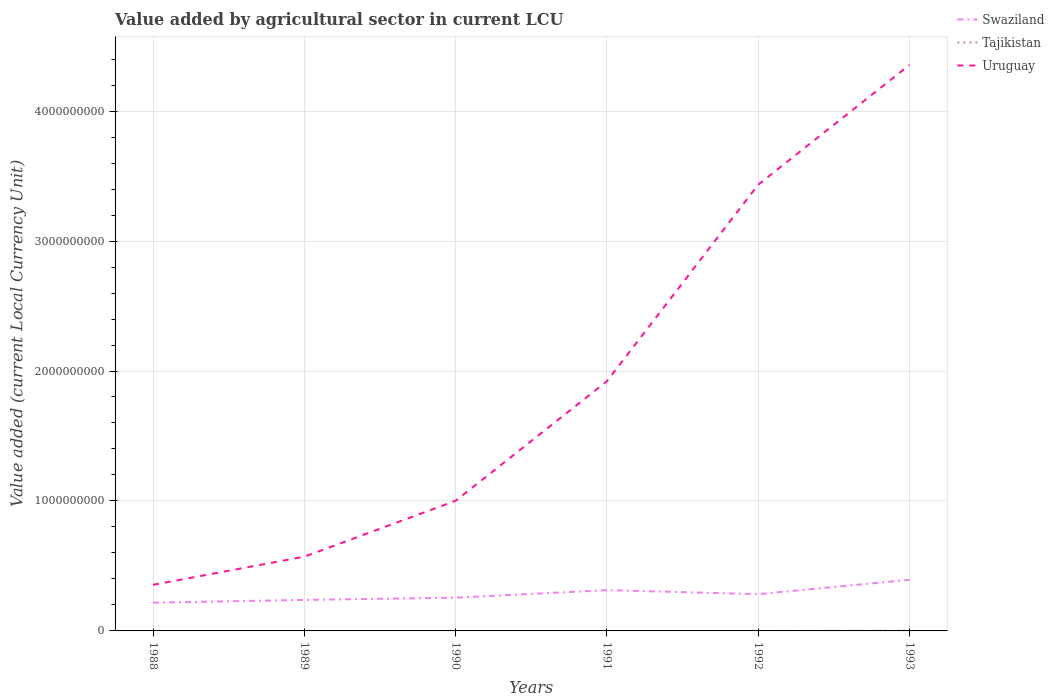How many different coloured lines are there?
Ensure brevity in your answer.  3. Does the line corresponding to Tajikistan intersect with the line corresponding to Swaziland?
Your answer should be very brief. No. Is the number of lines equal to the number of legend labels?
Your answer should be very brief. Yes. Across all years, what is the maximum value added by agricultural sector in Swaziland?
Offer a terse response. 2.17e+08. In which year was the value added by agricultural sector in Uruguay maximum?
Give a very brief answer. 1988. What is the total value added by agricultural sector in Tajikistan in the graph?
Your answer should be compact. -1.43e+06. What is the difference between the highest and the second highest value added by agricultural sector in Swaziland?
Give a very brief answer. 1.76e+08. How many lines are there?
Keep it short and to the point. 3. How many years are there in the graph?
Offer a terse response. 6. What is the difference between two consecutive major ticks on the Y-axis?
Ensure brevity in your answer.  1.00e+09. Where does the legend appear in the graph?
Ensure brevity in your answer.  Top right. How many legend labels are there?
Your answer should be compact. 3. How are the legend labels stacked?
Your response must be concise. Vertical. What is the title of the graph?
Keep it short and to the point. Value added by agricultural sector in current LCU. What is the label or title of the X-axis?
Offer a terse response. Years. What is the label or title of the Y-axis?
Ensure brevity in your answer.  Value added (current Local Currency Unit). What is the Value added (current Local Currency Unit) in Swaziland in 1988?
Offer a terse response. 2.17e+08. What is the Value added (current Local Currency Unit) of Tajikistan in 1988?
Ensure brevity in your answer.  2.18e+04. What is the Value added (current Local Currency Unit) of Uruguay in 1988?
Your answer should be compact. 3.55e+08. What is the Value added (current Local Currency Unit) in Swaziland in 1989?
Make the answer very short. 2.38e+08. What is the Value added (current Local Currency Unit) in Tajikistan in 1989?
Your answer should be very brief. 2.21e+04. What is the Value added (current Local Currency Unit) in Uruguay in 1989?
Ensure brevity in your answer.  5.71e+08. What is the Value added (current Local Currency Unit) in Swaziland in 1990?
Your response must be concise. 2.56e+08. What is the Value added (current Local Currency Unit) of Tajikistan in 1990?
Ensure brevity in your answer.  2.43e+04. What is the Value added (current Local Currency Unit) in Uruguay in 1990?
Give a very brief answer. 1.00e+09. What is the Value added (current Local Currency Unit) in Swaziland in 1991?
Keep it short and to the point. 3.14e+08. What is the Value added (current Local Currency Unit) in Tajikistan in 1991?
Provide a short and direct response. 4.88e+04. What is the Value added (current Local Currency Unit) of Uruguay in 1991?
Offer a very short reply. 1.92e+09. What is the Value added (current Local Currency Unit) of Swaziland in 1992?
Offer a terse response. 2.83e+08. What is the Value added (current Local Currency Unit) in Tajikistan in 1992?
Ensure brevity in your answer.  1.91e+05. What is the Value added (current Local Currency Unit) in Uruguay in 1992?
Offer a terse response. 3.43e+09. What is the Value added (current Local Currency Unit) of Swaziland in 1993?
Your answer should be very brief. 3.93e+08. What is the Value added (current Local Currency Unit) of Tajikistan in 1993?
Your answer should be very brief. 1.48e+06. What is the Value added (current Local Currency Unit) in Uruguay in 1993?
Your answer should be very brief. 4.36e+09. Across all years, what is the maximum Value added (current Local Currency Unit) in Swaziland?
Keep it short and to the point. 3.93e+08. Across all years, what is the maximum Value added (current Local Currency Unit) of Tajikistan?
Keep it short and to the point. 1.48e+06. Across all years, what is the maximum Value added (current Local Currency Unit) in Uruguay?
Your answer should be compact. 4.36e+09. Across all years, what is the minimum Value added (current Local Currency Unit) in Swaziland?
Provide a short and direct response. 2.17e+08. Across all years, what is the minimum Value added (current Local Currency Unit) of Tajikistan?
Offer a very short reply. 2.18e+04. Across all years, what is the minimum Value added (current Local Currency Unit) of Uruguay?
Your answer should be compact. 3.55e+08. What is the total Value added (current Local Currency Unit) in Swaziland in the graph?
Give a very brief answer. 1.70e+09. What is the total Value added (current Local Currency Unit) in Tajikistan in the graph?
Ensure brevity in your answer.  1.79e+06. What is the total Value added (current Local Currency Unit) in Uruguay in the graph?
Your answer should be compact. 1.16e+1. What is the difference between the Value added (current Local Currency Unit) in Swaziland in 1988 and that in 1989?
Offer a very short reply. -2.12e+07. What is the difference between the Value added (current Local Currency Unit) in Tajikistan in 1988 and that in 1989?
Ensure brevity in your answer.  -336.47. What is the difference between the Value added (current Local Currency Unit) in Uruguay in 1988 and that in 1989?
Offer a terse response. -2.17e+08. What is the difference between the Value added (current Local Currency Unit) in Swaziland in 1988 and that in 1990?
Keep it short and to the point. -3.86e+07. What is the difference between the Value added (current Local Currency Unit) of Tajikistan in 1988 and that in 1990?
Offer a terse response. -2468.71. What is the difference between the Value added (current Local Currency Unit) in Uruguay in 1988 and that in 1990?
Offer a terse response. -6.47e+08. What is the difference between the Value added (current Local Currency Unit) in Swaziland in 1988 and that in 1991?
Offer a very short reply. -9.66e+07. What is the difference between the Value added (current Local Currency Unit) in Tajikistan in 1988 and that in 1991?
Keep it short and to the point. -2.70e+04. What is the difference between the Value added (current Local Currency Unit) in Uruguay in 1988 and that in 1991?
Offer a very short reply. -1.57e+09. What is the difference between the Value added (current Local Currency Unit) of Swaziland in 1988 and that in 1992?
Your answer should be very brief. -6.56e+07. What is the difference between the Value added (current Local Currency Unit) of Tajikistan in 1988 and that in 1992?
Offer a terse response. -1.69e+05. What is the difference between the Value added (current Local Currency Unit) in Uruguay in 1988 and that in 1992?
Provide a short and direct response. -3.08e+09. What is the difference between the Value added (current Local Currency Unit) in Swaziland in 1988 and that in 1993?
Your answer should be very brief. -1.76e+08. What is the difference between the Value added (current Local Currency Unit) in Tajikistan in 1988 and that in 1993?
Make the answer very short. -1.46e+06. What is the difference between the Value added (current Local Currency Unit) of Uruguay in 1988 and that in 1993?
Provide a short and direct response. -4.00e+09. What is the difference between the Value added (current Local Currency Unit) of Swaziland in 1989 and that in 1990?
Provide a succinct answer. -1.74e+07. What is the difference between the Value added (current Local Currency Unit) in Tajikistan in 1989 and that in 1990?
Offer a very short reply. -2132.24. What is the difference between the Value added (current Local Currency Unit) in Uruguay in 1989 and that in 1990?
Your response must be concise. -4.30e+08. What is the difference between the Value added (current Local Currency Unit) of Swaziland in 1989 and that in 1991?
Keep it short and to the point. -7.54e+07. What is the difference between the Value added (current Local Currency Unit) of Tajikistan in 1989 and that in 1991?
Offer a terse response. -2.66e+04. What is the difference between the Value added (current Local Currency Unit) of Uruguay in 1989 and that in 1991?
Provide a short and direct response. -1.35e+09. What is the difference between the Value added (current Local Currency Unit) in Swaziland in 1989 and that in 1992?
Make the answer very short. -4.44e+07. What is the difference between the Value added (current Local Currency Unit) in Tajikistan in 1989 and that in 1992?
Offer a very short reply. -1.69e+05. What is the difference between the Value added (current Local Currency Unit) of Uruguay in 1989 and that in 1992?
Your answer should be very brief. -2.86e+09. What is the difference between the Value added (current Local Currency Unit) in Swaziland in 1989 and that in 1993?
Offer a terse response. -1.55e+08. What is the difference between the Value added (current Local Currency Unit) of Tajikistan in 1989 and that in 1993?
Provide a short and direct response. -1.46e+06. What is the difference between the Value added (current Local Currency Unit) of Uruguay in 1989 and that in 1993?
Keep it short and to the point. -3.78e+09. What is the difference between the Value added (current Local Currency Unit) of Swaziland in 1990 and that in 1991?
Offer a very short reply. -5.80e+07. What is the difference between the Value added (current Local Currency Unit) in Tajikistan in 1990 and that in 1991?
Your response must be concise. -2.45e+04. What is the difference between the Value added (current Local Currency Unit) in Uruguay in 1990 and that in 1991?
Make the answer very short. -9.20e+08. What is the difference between the Value added (current Local Currency Unit) in Swaziland in 1990 and that in 1992?
Your response must be concise. -2.70e+07. What is the difference between the Value added (current Local Currency Unit) of Tajikistan in 1990 and that in 1992?
Provide a succinct answer. -1.67e+05. What is the difference between the Value added (current Local Currency Unit) in Uruguay in 1990 and that in 1992?
Make the answer very short. -2.43e+09. What is the difference between the Value added (current Local Currency Unit) in Swaziland in 1990 and that in 1993?
Provide a short and direct response. -1.38e+08. What is the difference between the Value added (current Local Currency Unit) of Tajikistan in 1990 and that in 1993?
Offer a terse response. -1.46e+06. What is the difference between the Value added (current Local Currency Unit) of Uruguay in 1990 and that in 1993?
Keep it short and to the point. -3.35e+09. What is the difference between the Value added (current Local Currency Unit) in Swaziland in 1991 and that in 1992?
Provide a succinct answer. 3.10e+07. What is the difference between the Value added (current Local Currency Unit) of Tajikistan in 1991 and that in 1992?
Make the answer very short. -1.42e+05. What is the difference between the Value added (current Local Currency Unit) of Uruguay in 1991 and that in 1992?
Provide a short and direct response. -1.51e+09. What is the difference between the Value added (current Local Currency Unit) of Swaziland in 1991 and that in 1993?
Offer a terse response. -7.95e+07. What is the difference between the Value added (current Local Currency Unit) in Tajikistan in 1991 and that in 1993?
Give a very brief answer. -1.43e+06. What is the difference between the Value added (current Local Currency Unit) in Uruguay in 1991 and that in 1993?
Provide a succinct answer. -2.43e+09. What is the difference between the Value added (current Local Currency Unit) of Swaziland in 1992 and that in 1993?
Offer a terse response. -1.11e+08. What is the difference between the Value added (current Local Currency Unit) of Tajikistan in 1992 and that in 1993?
Offer a very short reply. -1.29e+06. What is the difference between the Value added (current Local Currency Unit) in Uruguay in 1992 and that in 1993?
Offer a very short reply. -9.22e+08. What is the difference between the Value added (current Local Currency Unit) of Swaziland in 1988 and the Value added (current Local Currency Unit) of Tajikistan in 1989?
Offer a very short reply. 2.17e+08. What is the difference between the Value added (current Local Currency Unit) in Swaziland in 1988 and the Value added (current Local Currency Unit) in Uruguay in 1989?
Offer a very short reply. -3.54e+08. What is the difference between the Value added (current Local Currency Unit) in Tajikistan in 1988 and the Value added (current Local Currency Unit) in Uruguay in 1989?
Give a very brief answer. -5.71e+08. What is the difference between the Value added (current Local Currency Unit) of Swaziland in 1988 and the Value added (current Local Currency Unit) of Tajikistan in 1990?
Offer a very short reply. 2.17e+08. What is the difference between the Value added (current Local Currency Unit) of Swaziland in 1988 and the Value added (current Local Currency Unit) of Uruguay in 1990?
Give a very brief answer. -7.84e+08. What is the difference between the Value added (current Local Currency Unit) in Tajikistan in 1988 and the Value added (current Local Currency Unit) in Uruguay in 1990?
Keep it short and to the point. -1.00e+09. What is the difference between the Value added (current Local Currency Unit) of Swaziland in 1988 and the Value added (current Local Currency Unit) of Tajikistan in 1991?
Make the answer very short. 2.17e+08. What is the difference between the Value added (current Local Currency Unit) in Swaziland in 1988 and the Value added (current Local Currency Unit) in Uruguay in 1991?
Provide a short and direct response. -1.70e+09. What is the difference between the Value added (current Local Currency Unit) of Tajikistan in 1988 and the Value added (current Local Currency Unit) of Uruguay in 1991?
Your response must be concise. -1.92e+09. What is the difference between the Value added (current Local Currency Unit) of Swaziland in 1988 and the Value added (current Local Currency Unit) of Tajikistan in 1992?
Offer a terse response. 2.17e+08. What is the difference between the Value added (current Local Currency Unit) in Swaziland in 1988 and the Value added (current Local Currency Unit) in Uruguay in 1992?
Your response must be concise. -3.22e+09. What is the difference between the Value added (current Local Currency Unit) in Tajikistan in 1988 and the Value added (current Local Currency Unit) in Uruguay in 1992?
Make the answer very short. -3.43e+09. What is the difference between the Value added (current Local Currency Unit) in Swaziland in 1988 and the Value added (current Local Currency Unit) in Tajikistan in 1993?
Provide a short and direct response. 2.16e+08. What is the difference between the Value added (current Local Currency Unit) in Swaziland in 1988 and the Value added (current Local Currency Unit) in Uruguay in 1993?
Your answer should be very brief. -4.14e+09. What is the difference between the Value added (current Local Currency Unit) of Tajikistan in 1988 and the Value added (current Local Currency Unit) of Uruguay in 1993?
Give a very brief answer. -4.36e+09. What is the difference between the Value added (current Local Currency Unit) of Swaziland in 1989 and the Value added (current Local Currency Unit) of Tajikistan in 1990?
Make the answer very short. 2.38e+08. What is the difference between the Value added (current Local Currency Unit) in Swaziland in 1989 and the Value added (current Local Currency Unit) in Uruguay in 1990?
Make the answer very short. -7.63e+08. What is the difference between the Value added (current Local Currency Unit) in Tajikistan in 1989 and the Value added (current Local Currency Unit) in Uruguay in 1990?
Provide a short and direct response. -1.00e+09. What is the difference between the Value added (current Local Currency Unit) in Swaziland in 1989 and the Value added (current Local Currency Unit) in Tajikistan in 1991?
Provide a short and direct response. 2.38e+08. What is the difference between the Value added (current Local Currency Unit) of Swaziland in 1989 and the Value added (current Local Currency Unit) of Uruguay in 1991?
Your response must be concise. -1.68e+09. What is the difference between the Value added (current Local Currency Unit) in Tajikistan in 1989 and the Value added (current Local Currency Unit) in Uruguay in 1991?
Your answer should be compact. -1.92e+09. What is the difference between the Value added (current Local Currency Unit) of Swaziland in 1989 and the Value added (current Local Currency Unit) of Tajikistan in 1992?
Offer a very short reply. 2.38e+08. What is the difference between the Value added (current Local Currency Unit) of Swaziland in 1989 and the Value added (current Local Currency Unit) of Uruguay in 1992?
Your answer should be very brief. -3.20e+09. What is the difference between the Value added (current Local Currency Unit) of Tajikistan in 1989 and the Value added (current Local Currency Unit) of Uruguay in 1992?
Your answer should be compact. -3.43e+09. What is the difference between the Value added (current Local Currency Unit) of Swaziland in 1989 and the Value added (current Local Currency Unit) of Tajikistan in 1993?
Offer a terse response. 2.37e+08. What is the difference between the Value added (current Local Currency Unit) in Swaziland in 1989 and the Value added (current Local Currency Unit) in Uruguay in 1993?
Offer a terse response. -4.12e+09. What is the difference between the Value added (current Local Currency Unit) in Tajikistan in 1989 and the Value added (current Local Currency Unit) in Uruguay in 1993?
Make the answer very short. -4.36e+09. What is the difference between the Value added (current Local Currency Unit) of Swaziland in 1990 and the Value added (current Local Currency Unit) of Tajikistan in 1991?
Your response must be concise. 2.56e+08. What is the difference between the Value added (current Local Currency Unit) in Swaziland in 1990 and the Value added (current Local Currency Unit) in Uruguay in 1991?
Provide a short and direct response. -1.67e+09. What is the difference between the Value added (current Local Currency Unit) of Tajikistan in 1990 and the Value added (current Local Currency Unit) of Uruguay in 1991?
Give a very brief answer. -1.92e+09. What is the difference between the Value added (current Local Currency Unit) of Swaziland in 1990 and the Value added (current Local Currency Unit) of Tajikistan in 1992?
Provide a succinct answer. 2.56e+08. What is the difference between the Value added (current Local Currency Unit) of Swaziland in 1990 and the Value added (current Local Currency Unit) of Uruguay in 1992?
Ensure brevity in your answer.  -3.18e+09. What is the difference between the Value added (current Local Currency Unit) of Tajikistan in 1990 and the Value added (current Local Currency Unit) of Uruguay in 1992?
Give a very brief answer. -3.43e+09. What is the difference between the Value added (current Local Currency Unit) of Swaziland in 1990 and the Value added (current Local Currency Unit) of Tajikistan in 1993?
Offer a very short reply. 2.54e+08. What is the difference between the Value added (current Local Currency Unit) of Swaziland in 1990 and the Value added (current Local Currency Unit) of Uruguay in 1993?
Give a very brief answer. -4.10e+09. What is the difference between the Value added (current Local Currency Unit) of Tajikistan in 1990 and the Value added (current Local Currency Unit) of Uruguay in 1993?
Offer a very short reply. -4.36e+09. What is the difference between the Value added (current Local Currency Unit) of Swaziland in 1991 and the Value added (current Local Currency Unit) of Tajikistan in 1992?
Your answer should be very brief. 3.14e+08. What is the difference between the Value added (current Local Currency Unit) in Swaziland in 1991 and the Value added (current Local Currency Unit) in Uruguay in 1992?
Keep it short and to the point. -3.12e+09. What is the difference between the Value added (current Local Currency Unit) of Tajikistan in 1991 and the Value added (current Local Currency Unit) of Uruguay in 1992?
Your answer should be very brief. -3.43e+09. What is the difference between the Value added (current Local Currency Unit) of Swaziland in 1991 and the Value added (current Local Currency Unit) of Tajikistan in 1993?
Provide a succinct answer. 3.12e+08. What is the difference between the Value added (current Local Currency Unit) in Swaziland in 1991 and the Value added (current Local Currency Unit) in Uruguay in 1993?
Offer a very short reply. -4.04e+09. What is the difference between the Value added (current Local Currency Unit) of Tajikistan in 1991 and the Value added (current Local Currency Unit) of Uruguay in 1993?
Provide a succinct answer. -4.36e+09. What is the difference between the Value added (current Local Currency Unit) in Swaziland in 1992 and the Value added (current Local Currency Unit) in Tajikistan in 1993?
Keep it short and to the point. 2.81e+08. What is the difference between the Value added (current Local Currency Unit) of Swaziland in 1992 and the Value added (current Local Currency Unit) of Uruguay in 1993?
Your answer should be very brief. -4.07e+09. What is the difference between the Value added (current Local Currency Unit) in Tajikistan in 1992 and the Value added (current Local Currency Unit) in Uruguay in 1993?
Offer a terse response. -4.36e+09. What is the average Value added (current Local Currency Unit) of Swaziland per year?
Your answer should be very brief. 2.84e+08. What is the average Value added (current Local Currency Unit) of Tajikistan per year?
Make the answer very short. 2.99e+05. What is the average Value added (current Local Currency Unit) in Uruguay per year?
Provide a short and direct response. 1.94e+09. In the year 1988, what is the difference between the Value added (current Local Currency Unit) of Swaziland and Value added (current Local Currency Unit) of Tajikistan?
Your response must be concise. 2.17e+08. In the year 1988, what is the difference between the Value added (current Local Currency Unit) in Swaziland and Value added (current Local Currency Unit) in Uruguay?
Your response must be concise. -1.37e+08. In the year 1988, what is the difference between the Value added (current Local Currency Unit) of Tajikistan and Value added (current Local Currency Unit) of Uruguay?
Give a very brief answer. -3.55e+08. In the year 1989, what is the difference between the Value added (current Local Currency Unit) of Swaziland and Value added (current Local Currency Unit) of Tajikistan?
Offer a very short reply. 2.38e+08. In the year 1989, what is the difference between the Value added (current Local Currency Unit) of Swaziland and Value added (current Local Currency Unit) of Uruguay?
Your answer should be very brief. -3.33e+08. In the year 1989, what is the difference between the Value added (current Local Currency Unit) in Tajikistan and Value added (current Local Currency Unit) in Uruguay?
Offer a very short reply. -5.71e+08. In the year 1990, what is the difference between the Value added (current Local Currency Unit) of Swaziland and Value added (current Local Currency Unit) of Tajikistan?
Provide a succinct answer. 2.56e+08. In the year 1990, what is the difference between the Value added (current Local Currency Unit) of Swaziland and Value added (current Local Currency Unit) of Uruguay?
Make the answer very short. -7.46e+08. In the year 1990, what is the difference between the Value added (current Local Currency Unit) of Tajikistan and Value added (current Local Currency Unit) of Uruguay?
Offer a terse response. -1.00e+09. In the year 1991, what is the difference between the Value added (current Local Currency Unit) of Swaziland and Value added (current Local Currency Unit) of Tajikistan?
Your answer should be very brief. 3.14e+08. In the year 1991, what is the difference between the Value added (current Local Currency Unit) in Swaziland and Value added (current Local Currency Unit) in Uruguay?
Your answer should be compact. -1.61e+09. In the year 1991, what is the difference between the Value added (current Local Currency Unit) in Tajikistan and Value added (current Local Currency Unit) in Uruguay?
Offer a very short reply. -1.92e+09. In the year 1992, what is the difference between the Value added (current Local Currency Unit) of Swaziland and Value added (current Local Currency Unit) of Tajikistan?
Keep it short and to the point. 2.83e+08. In the year 1992, what is the difference between the Value added (current Local Currency Unit) of Swaziland and Value added (current Local Currency Unit) of Uruguay?
Your answer should be compact. -3.15e+09. In the year 1992, what is the difference between the Value added (current Local Currency Unit) of Tajikistan and Value added (current Local Currency Unit) of Uruguay?
Your response must be concise. -3.43e+09. In the year 1993, what is the difference between the Value added (current Local Currency Unit) in Swaziland and Value added (current Local Currency Unit) in Tajikistan?
Your answer should be compact. 3.92e+08. In the year 1993, what is the difference between the Value added (current Local Currency Unit) of Swaziland and Value added (current Local Currency Unit) of Uruguay?
Offer a terse response. -3.96e+09. In the year 1993, what is the difference between the Value added (current Local Currency Unit) of Tajikistan and Value added (current Local Currency Unit) of Uruguay?
Give a very brief answer. -4.35e+09. What is the ratio of the Value added (current Local Currency Unit) of Swaziland in 1988 to that in 1989?
Make the answer very short. 0.91. What is the ratio of the Value added (current Local Currency Unit) of Tajikistan in 1988 to that in 1989?
Offer a terse response. 0.98. What is the ratio of the Value added (current Local Currency Unit) in Uruguay in 1988 to that in 1989?
Offer a very short reply. 0.62. What is the ratio of the Value added (current Local Currency Unit) in Swaziland in 1988 to that in 1990?
Offer a terse response. 0.85. What is the ratio of the Value added (current Local Currency Unit) of Tajikistan in 1988 to that in 1990?
Your response must be concise. 0.9. What is the ratio of the Value added (current Local Currency Unit) of Uruguay in 1988 to that in 1990?
Ensure brevity in your answer.  0.35. What is the ratio of the Value added (current Local Currency Unit) in Swaziland in 1988 to that in 1991?
Keep it short and to the point. 0.69. What is the ratio of the Value added (current Local Currency Unit) of Tajikistan in 1988 to that in 1991?
Make the answer very short. 0.45. What is the ratio of the Value added (current Local Currency Unit) in Uruguay in 1988 to that in 1991?
Give a very brief answer. 0.18. What is the ratio of the Value added (current Local Currency Unit) in Swaziland in 1988 to that in 1992?
Your response must be concise. 0.77. What is the ratio of the Value added (current Local Currency Unit) of Tajikistan in 1988 to that in 1992?
Make the answer very short. 0.11. What is the ratio of the Value added (current Local Currency Unit) in Uruguay in 1988 to that in 1992?
Provide a short and direct response. 0.1. What is the ratio of the Value added (current Local Currency Unit) of Swaziland in 1988 to that in 1993?
Your response must be concise. 0.55. What is the ratio of the Value added (current Local Currency Unit) in Tajikistan in 1988 to that in 1993?
Provide a short and direct response. 0.01. What is the ratio of the Value added (current Local Currency Unit) of Uruguay in 1988 to that in 1993?
Your answer should be compact. 0.08. What is the ratio of the Value added (current Local Currency Unit) in Swaziland in 1989 to that in 1990?
Provide a succinct answer. 0.93. What is the ratio of the Value added (current Local Currency Unit) in Tajikistan in 1989 to that in 1990?
Make the answer very short. 0.91. What is the ratio of the Value added (current Local Currency Unit) of Uruguay in 1989 to that in 1990?
Your response must be concise. 0.57. What is the ratio of the Value added (current Local Currency Unit) in Swaziland in 1989 to that in 1991?
Provide a succinct answer. 0.76. What is the ratio of the Value added (current Local Currency Unit) of Tajikistan in 1989 to that in 1991?
Ensure brevity in your answer.  0.45. What is the ratio of the Value added (current Local Currency Unit) of Uruguay in 1989 to that in 1991?
Offer a terse response. 0.3. What is the ratio of the Value added (current Local Currency Unit) in Swaziland in 1989 to that in 1992?
Keep it short and to the point. 0.84. What is the ratio of the Value added (current Local Currency Unit) in Tajikistan in 1989 to that in 1992?
Provide a succinct answer. 0.12. What is the ratio of the Value added (current Local Currency Unit) of Uruguay in 1989 to that in 1992?
Your answer should be very brief. 0.17. What is the ratio of the Value added (current Local Currency Unit) of Swaziland in 1989 to that in 1993?
Give a very brief answer. 0.61. What is the ratio of the Value added (current Local Currency Unit) in Tajikistan in 1989 to that in 1993?
Ensure brevity in your answer.  0.01. What is the ratio of the Value added (current Local Currency Unit) in Uruguay in 1989 to that in 1993?
Provide a short and direct response. 0.13. What is the ratio of the Value added (current Local Currency Unit) in Swaziland in 1990 to that in 1991?
Make the answer very short. 0.82. What is the ratio of the Value added (current Local Currency Unit) in Tajikistan in 1990 to that in 1991?
Offer a terse response. 0.5. What is the ratio of the Value added (current Local Currency Unit) of Uruguay in 1990 to that in 1991?
Your response must be concise. 0.52. What is the ratio of the Value added (current Local Currency Unit) of Swaziland in 1990 to that in 1992?
Keep it short and to the point. 0.9. What is the ratio of the Value added (current Local Currency Unit) in Tajikistan in 1990 to that in 1992?
Make the answer very short. 0.13. What is the ratio of the Value added (current Local Currency Unit) of Uruguay in 1990 to that in 1992?
Make the answer very short. 0.29. What is the ratio of the Value added (current Local Currency Unit) in Swaziland in 1990 to that in 1993?
Offer a very short reply. 0.65. What is the ratio of the Value added (current Local Currency Unit) of Tajikistan in 1990 to that in 1993?
Your answer should be very brief. 0.02. What is the ratio of the Value added (current Local Currency Unit) of Uruguay in 1990 to that in 1993?
Your answer should be compact. 0.23. What is the ratio of the Value added (current Local Currency Unit) in Swaziland in 1991 to that in 1992?
Make the answer very short. 1.11. What is the ratio of the Value added (current Local Currency Unit) in Tajikistan in 1991 to that in 1992?
Keep it short and to the point. 0.26. What is the ratio of the Value added (current Local Currency Unit) in Uruguay in 1991 to that in 1992?
Your answer should be compact. 0.56. What is the ratio of the Value added (current Local Currency Unit) of Swaziland in 1991 to that in 1993?
Your answer should be compact. 0.8. What is the ratio of the Value added (current Local Currency Unit) of Tajikistan in 1991 to that in 1993?
Your answer should be compact. 0.03. What is the ratio of the Value added (current Local Currency Unit) in Uruguay in 1991 to that in 1993?
Offer a very short reply. 0.44. What is the ratio of the Value added (current Local Currency Unit) in Swaziland in 1992 to that in 1993?
Give a very brief answer. 0.72. What is the ratio of the Value added (current Local Currency Unit) of Tajikistan in 1992 to that in 1993?
Make the answer very short. 0.13. What is the ratio of the Value added (current Local Currency Unit) of Uruguay in 1992 to that in 1993?
Provide a succinct answer. 0.79. What is the difference between the highest and the second highest Value added (current Local Currency Unit) of Swaziland?
Your response must be concise. 7.95e+07. What is the difference between the highest and the second highest Value added (current Local Currency Unit) in Tajikistan?
Give a very brief answer. 1.29e+06. What is the difference between the highest and the second highest Value added (current Local Currency Unit) of Uruguay?
Ensure brevity in your answer.  9.22e+08. What is the difference between the highest and the lowest Value added (current Local Currency Unit) of Swaziland?
Make the answer very short. 1.76e+08. What is the difference between the highest and the lowest Value added (current Local Currency Unit) in Tajikistan?
Provide a succinct answer. 1.46e+06. What is the difference between the highest and the lowest Value added (current Local Currency Unit) in Uruguay?
Your response must be concise. 4.00e+09. 